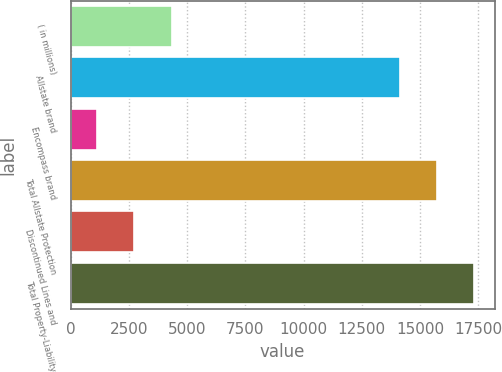Convert chart to OTSL. <chart><loc_0><loc_0><loc_500><loc_500><bar_chart><fcel>( in millions)<fcel>Allstate brand<fcel>Encompass brand<fcel>Total Allstate Protection<fcel>Discontinued Lines and<fcel>Total Property-Liability<nl><fcel>4342.8<fcel>14118<fcel>1133<fcel>15722.9<fcel>2737.9<fcel>17327.8<nl></chart> 